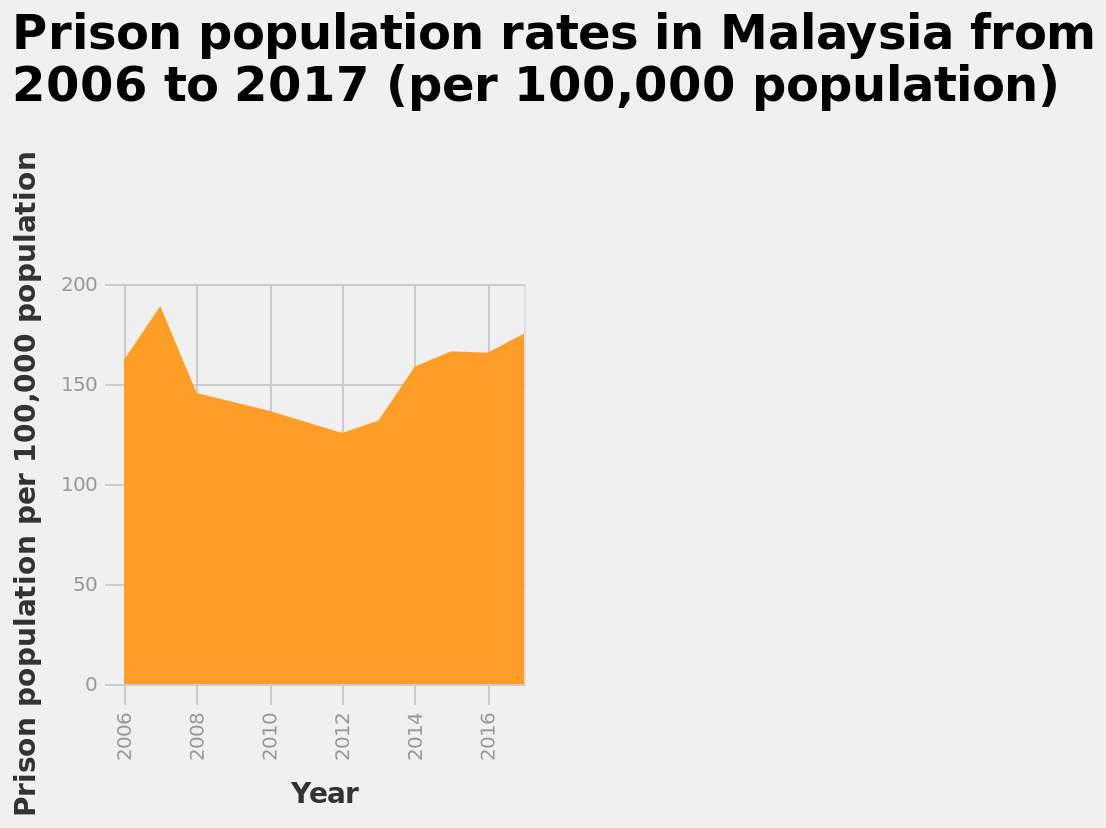<image>
When did the decline in the prison population rate in Malaysia end?  The decline in the prison population rate in Malaysia ended in 2012. 